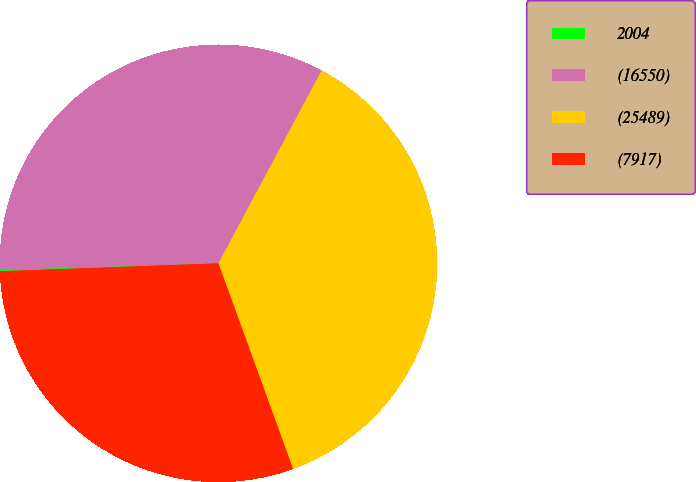Convert chart to OTSL. <chart><loc_0><loc_0><loc_500><loc_500><pie_chart><fcel>2004<fcel>(16550)<fcel>(25489)<fcel>(7917)<nl><fcel>0.1%<fcel>33.3%<fcel>36.63%<fcel>29.97%<nl></chart> 